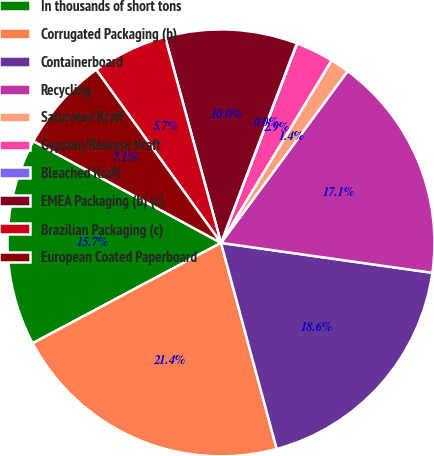<chart> <loc_0><loc_0><loc_500><loc_500><pie_chart><fcel>In thousands of short tons<fcel>Corrugated Packaging (b)<fcel>Containerboard<fcel>Recycling<fcel>Saturated Kraft<fcel>Gypsum/Release Kraft<fcel>Bleached Kraft<fcel>EMEA Packaging (b) (c)<fcel>Brazilian Packaging (c)<fcel>European Coated Paperboard<nl><fcel>15.7%<fcel>21.41%<fcel>18.56%<fcel>17.13%<fcel>1.44%<fcel>2.87%<fcel>0.02%<fcel>10.0%<fcel>5.72%<fcel>7.15%<nl></chart> 